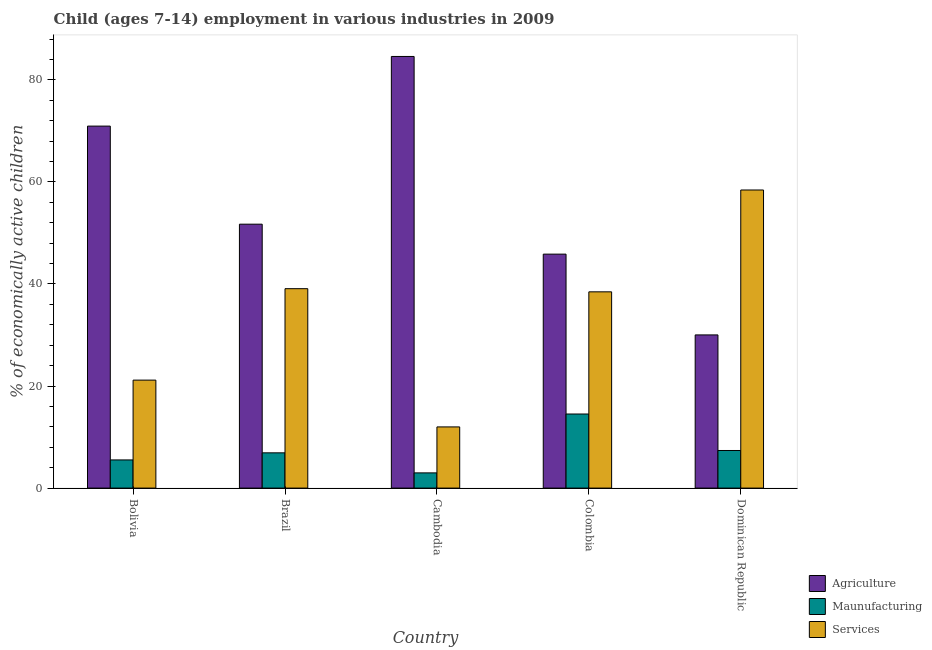How many different coloured bars are there?
Your answer should be compact. 3. Are the number of bars per tick equal to the number of legend labels?
Offer a very short reply. Yes. Are the number of bars on each tick of the X-axis equal?
Your response must be concise. Yes. How many bars are there on the 1st tick from the left?
Offer a very short reply. 3. What is the label of the 3rd group of bars from the left?
Keep it short and to the point. Cambodia. What is the percentage of economically active children in agriculture in Cambodia?
Offer a terse response. 84.59. Across all countries, what is the maximum percentage of economically active children in services?
Offer a terse response. 58.42. Across all countries, what is the minimum percentage of economically active children in manufacturing?
Keep it short and to the point. 2.98. In which country was the percentage of economically active children in services maximum?
Give a very brief answer. Dominican Republic. In which country was the percentage of economically active children in manufacturing minimum?
Ensure brevity in your answer.  Cambodia. What is the total percentage of economically active children in services in the graph?
Provide a short and direct response. 169.11. What is the difference between the percentage of economically active children in services in Cambodia and that in Colombia?
Offer a terse response. -26.47. What is the difference between the percentage of economically active children in services in Brazil and the percentage of economically active children in manufacturing in Colombia?
Provide a short and direct response. 24.56. What is the average percentage of economically active children in services per country?
Give a very brief answer. 33.82. What is the difference between the percentage of economically active children in agriculture and percentage of economically active children in services in Brazil?
Provide a succinct answer. 12.64. In how many countries, is the percentage of economically active children in manufacturing greater than 16 %?
Offer a very short reply. 0. What is the ratio of the percentage of economically active children in services in Brazil to that in Dominican Republic?
Offer a terse response. 0.67. What is the difference between the highest and the second highest percentage of economically active children in services?
Your response must be concise. 19.34. What is the difference between the highest and the lowest percentage of economically active children in services?
Make the answer very short. 46.43. In how many countries, is the percentage of economically active children in manufacturing greater than the average percentage of economically active children in manufacturing taken over all countries?
Provide a succinct answer. 1. Is the sum of the percentage of economically active children in manufacturing in Bolivia and Dominican Republic greater than the maximum percentage of economically active children in agriculture across all countries?
Ensure brevity in your answer.  No. What does the 2nd bar from the left in Colombia represents?
Ensure brevity in your answer.  Maunufacturing. What does the 2nd bar from the right in Bolivia represents?
Offer a very short reply. Maunufacturing. How many bars are there?
Ensure brevity in your answer.  15. Are all the bars in the graph horizontal?
Your answer should be compact. No. What is the difference between two consecutive major ticks on the Y-axis?
Ensure brevity in your answer.  20. Are the values on the major ticks of Y-axis written in scientific E-notation?
Your response must be concise. No. Where does the legend appear in the graph?
Offer a very short reply. Bottom right. How are the legend labels stacked?
Offer a terse response. Vertical. What is the title of the graph?
Ensure brevity in your answer.  Child (ages 7-14) employment in various industries in 2009. What is the label or title of the X-axis?
Offer a terse response. Country. What is the label or title of the Y-axis?
Your answer should be very brief. % of economically active children. What is the % of economically active children in Agriculture in Bolivia?
Offer a very short reply. 70.94. What is the % of economically active children of Maunufacturing in Bolivia?
Your answer should be compact. 5.52. What is the % of economically active children in Services in Bolivia?
Ensure brevity in your answer.  21.16. What is the % of economically active children of Agriculture in Brazil?
Your answer should be very brief. 51.72. What is the % of economically active children of Maunufacturing in Brazil?
Provide a succinct answer. 6.91. What is the % of economically active children of Services in Brazil?
Your answer should be very brief. 39.08. What is the % of economically active children of Agriculture in Cambodia?
Your answer should be compact. 84.59. What is the % of economically active children of Maunufacturing in Cambodia?
Offer a very short reply. 2.98. What is the % of economically active children in Services in Cambodia?
Give a very brief answer. 11.99. What is the % of economically active children in Agriculture in Colombia?
Your answer should be compact. 45.85. What is the % of economically active children in Maunufacturing in Colombia?
Make the answer very short. 14.52. What is the % of economically active children of Services in Colombia?
Make the answer very short. 38.46. What is the % of economically active children of Agriculture in Dominican Republic?
Your response must be concise. 30.02. What is the % of economically active children of Maunufacturing in Dominican Republic?
Offer a terse response. 7.37. What is the % of economically active children in Services in Dominican Republic?
Your response must be concise. 58.42. Across all countries, what is the maximum % of economically active children in Agriculture?
Make the answer very short. 84.59. Across all countries, what is the maximum % of economically active children in Maunufacturing?
Ensure brevity in your answer.  14.52. Across all countries, what is the maximum % of economically active children of Services?
Offer a very short reply. 58.42. Across all countries, what is the minimum % of economically active children in Agriculture?
Provide a succinct answer. 30.02. Across all countries, what is the minimum % of economically active children in Maunufacturing?
Make the answer very short. 2.98. Across all countries, what is the minimum % of economically active children of Services?
Offer a terse response. 11.99. What is the total % of economically active children in Agriculture in the graph?
Make the answer very short. 283.12. What is the total % of economically active children in Maunufacturing in the graph?
Your response must be concise. 37.3. What is the total % of economically active children of Services in the graph?
Keep it short and to the point. 169.11. What is the difference between the % of economically active children of Agriculture in Bolivia and that in Brazil?
Make the answer very short. 19.22. What is the difference between the % of economically active children in Maunufacturing in Bolivia and that in Brazil?
Keep it short and to the point. -1.39. What is the difference between the % of economically active children in Services in Bolivia and that in Brazil?
Provide a succinct answer. -17.92. What is the difference between the % of economically active children of Agriculture in Bolivia and that in Cambodia?
Provide a short and direct response. -13.65. What is the difference between the % of economically active children in Maunufacturing in Bolivia and that in Cambodia?
Offer a terse response. 2.54. What is the difference between the % of economically active children of Services in Bolivia and that in Cambodia?
Your answer should be compact. 9.17. What is the difference between the % of economically active children in Agriculture in Bolivia and that in Colombia?
Give a very brief answer. 25.09. What is the difference between the % of economically active children in Services in Bolivia and that in Colombia?
Your answer should be compact. -17.3. What is the difference between the % of economically active children of Agriculture in Bolivia and that in Dominican Republic?
Your answer should be very brief. 40.92. What is the difference between the % of economically active children of Maunufacturing in Bolivia and that in Dominican Republic?
Your answer should be very brief. -1.85. What is the difference between the % of economically active children in Services in Bolivia and that in Dominican Republic?
Provide a short and direct response. -37.26. What is the difference between the % of economically active children in Agriculture in Brazil and that in Cambodia?
Offer a terse response. -32.87. What is the difference between the % of economically active children in Maunufacturing in Brazil and that in Cambodia?
Provide a short and direct response. 3.93. What is the difference between the % of economically active children in Services in Brazil and that in Cambodia?
Your response must be concise. 27.09. What is the difference between the % of economically active children of Agriculture in Brazil and that in Colombia?
Make the answer very short. 5.87. What is the difference between the % of economically active children of Maunufacturing in Brazil and that in Colombia?
Make the answer very short. -7.61. What is the difference between the % of economically active children in Services in Brazil and that in Colombia?
Make the answer very short. 0.62. What is the difference between the % of economically active children in Agriculture in Brazil and that in Dominican Republic?
Keep it short and to the point. 21.7. What is the difference between the % of economically active children of Maunufacturing in Brazil and that in Dominican Republic?
Offer a very short reply. -0.46. What is the difference between the % of economically active children of Services in Brazil and that in Dominican Republic?
Provide a succinct answer. -19.34. What is the difference between the % of economically active children in Agriculture in Cambodia and that in Colombia?
Keep it short and to the point. 38.74. What is the difference between the % of economically active children in Maunufacturing in Cambodia and that in Colombia?
Offer a terse response. -11.54. What is the difference between the % of economically active children in Services in Cambodia and that in Colombia?
Offer a terse response. -26.47. What is the difference between the % of economically active children in Agriculture in Cambodia and that in Dominican Republic?
Provide a succinct answer. 54.57. What is the difference between the % of economically active children of Maunufacturing in Cambodia and that in Dominican Republic?
Ensure brevity in your answer.  -4.39. What is the difference between the % of economically active children in Services in Cambodia and that in Dominican Republic?
Offer a very short reply. -46.43. What is the difference between the % of economically active children of Agriculture in Colombia and that in Dominican Republic?
Your answer should be very brief. 15.83. What is the difference between the % of economically active children of Maunufacturing in Colombia and that in Dominican Republic?
Your response must be concise. 7.15. What is the difference between the % of economically active children of Services in Colombia and that in Dominican Republic?
Provide a succinct answer. -19.96. What is the difference between the % of economically active children of Agriculture in Bolivia and the % of economically active children of Maunufacturing in Brazil?
Give a very brief answer. 64.03. What is the difference between the % of economically active children of Agriculture in Bolivia and the % of economically active children of Services in Brazil?
Make the answer very short. 31.86. What is the difference between the % of economically active children of Maunufacturing in Bolivia and the % of economically active children of Services in Brazil?
Give a very brief answer. -33.56. What is the difference between the % of economically active children in Agriculture in Bolivia and the % of economically active children in Maunufacturing in Cambodia?
Your response must be concise. 67.96. What is the difference between the % of economically active children in Agriculture in Bolivia and the % of economically active children in Services in Cambodia?
Your answer should be very brief. 58.95. What is the difference between the % of economically active children of Maunufacturing in Bolivia and the % of economically active children of Services in Cambodia?
Ensure brevity in your answer.  -6.47. What is the difference between the % of economically active children in Agriculture in Bolivia and the % of economically active children in Maunufacturing in Colombia?
Offer a terse response. 56.42. What is the difference between the % of economically active children in Agriculture in Bolivia and the % of economically active children in Services in Colombia?
Your response must be concise. 32.48. What is the difference between the % of economically active children of Maunufacturing in Bolivia and the % of economically active children of Services in Colombia?
Your response must be concise. -32.94. What is the difference between the % of economically active children of Agriculture in Bolivia and the % of economically active children of Maunufacturing in Dominican Republic?
Provide a short and direct response. 63.57. What is the difference between the % of economically active children in Agriculture in Bolivia and the % of economically active children in Services in Dominican Republic?
Give a very brief answer. 12.52. What is the difference between the % of economically active children in Maunufacturing in Bolivia and the % of economically active children in Services in Dominican Republic?
Offer a very short reply. -52.9. What is the difference between the % of economically active children in Agriculture in Brazil and the % of economically active children in Maunufacturing in Cambodia?
Make the answer very short. 48.74. What is the difference between the % of economically active children in Agriculture in Brazil and the % of economically active children in Services in Cambodia?
Ensure brevity in your answer.  39.73. What is the difference between the % of economically active children of Maunufacturing in Brazil and the % of economically active children of Services in Cambodia?
Keep it short and to the point. -5.08. What is the difference between the % of economically active children of Agriculture in Brazil and the % of economically active children of Maunufacturing in Colombia?
Make the answer very short. 37.2. What is the difference between the % of economically active children in Agriculture in Brazil and the % of economically active children in Services in Colombia?
Offer a terse response. 13.26. What is the difference between the % of economically active children in Maunufacturing in Brazil and the % of economically active children in Services in Colombia?
Provide a succinct answer. -31.55. What is the difference between the % of economically active children in Agriculture in Brazil and the % of economically active children in Maunufacturing in Dominican Republic?
Your answer should be very brief. 44.35. What is the difference between the % of economically active children in Maunufacturing in Brazil and the % of economically active children in Services in Dominican Republic?
Provide a short and direct response. -51.51. What is the difference between the % of economically active children in Agriculture in Cambodia and the % of economically active children in Maunufacturing in Colombia?
Ensure brevity in your answer.  70.07. What is the difference between the % of economically active children of Agriculture in Cambodia and the % of economically active children of Services in Colombia?
Provide a succinct answer. 46.13. What is the difference between the % of economically active children of Maunufacturing in Cambodia and the % of economically active children of Services in Colombia?
Your response must be concise. -35.48. What is the difference between the % of economically active children of Agriculture in Cambodia and the % of economically active children of Maunufacturing in Dominican Republic?
Offer a terse response. 77.22. What is the difference between the % of economically active children of Agriculture in Cambodia and the % of economically active children of Services in Dominican Republic?
Offer a terse response. 26.17. What is the difference between the % of economically active children in Maunufacturing in Cambodia and the % of economically active children in Services in Dominican Republic?
Ensure brevity in your answer.  -55.44. What is the difference between the % of economically active children of Agriculture in Colombia and the % of economically active children of Maunufacturing in Dominican Republic?
Your response must be concise. 38.48. What is the difference between the % of economically active children of Agriculture in Colombia and the % of economically active children of Services in Dominican Republic?
Your answer should be very brief. -12.57. What is the difference between the % of economically active children of Maunufacturing in Colombia and the % of economically active children of Services in Dominican Republic?
Provide a short and direct response. -43.9. What is the average % of economically active children of Agriculture per country?
Offer a terse response. 56.62. What is the average % of economically active children in Maunufacturing per country?
Provide a succinct answer. 7.46. What is the average % of economically active children of Services per country?
Make the answer very short. 33.82. What is the difference between the % of economically active children in Agriculture and % of economically active children in Maunufacturing in Bolivia?
Give a very brief answer. 65.42. What is the difference between the % of economically active children in Agriculture and % of economically active children in Services in Bolivia?
Make the answer very short. 49.78. What is the difference between the % of economically active children of Maunufacturing and % of economically active children of Services in Bolivia?
Your answer should be compact. -15.64. What is the difference between the % of economically active children of Agriculture and % of economically active children of Maunufacturing in Brazil?
Keep it short and to the point. 44.81. What is the difference between the % of economically active children of Agriculture and % of economically active children of Services in Brazil?
Your response must be concise. 12.64. What is the difference between the % of economically active children in Maunufacturing and % of economically active children in Services in Brazil?
Offer a terse response. -32.17. What is the difference between the % of economically active children in Agriculture and % of economically active children in Maunufacturing in Cambodia?
Your answer should be compact. 81.61. What is the difference between the % of economically active children in Agriculture and % of economically active children in Services in Cambodia?
Ensure brevity in your answer.  72.6. What is the difference between the % of economically active children of Maunufacturing and % of economically active children of Services in Cambodia?
Your answer should be very brief. -9.01. What is the difference between the % of economically active children of Agriculture and % of economically active children of Maunufacturing in Colombia?
Make the answer very short. 31.33. What is the difference between the % of economically active children in Agriculture and % of economically active children in Services in Colombia?
Keep it short and to the point. 7.39. What is the difference between the % of economically active children of Maunufacturing and % of economically active children of Services in Colombia?
Provide a short and direct response. -23.94. What is the difference between the % of economically active children of Agriculture and % of economically active children of Maunufacturing in Dominican Republic?
Provide a succinct answer. 22.65. What is the difference between the % of economically active children of Agriculture and % of economically active children of Services in Dominican Republic?
Your response must be concise. -28.4. What is the difference between the % of economically active children in Maunufacturing and % of economically active children in Services in Dominican Republic?
Your answer should be compact. -51.05. What is the ratio of the % of economically active children in Agriculture in Bolivia to that in Brazil?
Ensure brevity in your answer.  1.37. What is the ratio of the % of economically active children in Maunufacturing in Bolivia to that in Brazil?
Keep it short and to the point. 0.8. What is the ratio of the % of economically active children of Services in Bolivia to that in Brazil?
Your answer should be compact. 0.54. What is the ratio of the % of economically active children of Agriculture in Bolivia to that in Cambodia?
Your response must be concise. 0.84. What is the ratio of the % of economically active children in Maunufacturing in Bolivia to that in Cambodia?
Offer a very short reply. 1.85. What is the ratio of the % of economically active children in Services in Bolivia to that in Cambodia?
Your answer should be very brief. 1.76. What is the ratio of the % of economically active children in Agriculture in Bolivia to that in Colombia?
Your response must be concise. 1.55. What is the ratio of the % of economically active children in Maunufacturing in Bolivia to that in Colombia?
Give a very brief answer. 0.38. What is the ratio of the % of economically active children in Services in Bolivia to that in Colombia?
Make the answer very short. 0.55. What is the ratio of the % of economically active children of Agriculture in Bolivia to that in Dominican Republic?
Offer a very short reply. 2.36. What is the ratio of the % of economically active children in Maunufacturing in Bolivia to that in Dominican Republic?
Offer a terse response. 0.75. What is the ratio of the % of economically active children of Services in Bolivia to that in Dominican Republic?
Offer a very short reply. 0.36. What is the ratio of the % of economically active children in Agriculture in Brazil to that in Cambodia?
Offer a terse response. 0.61. What is the ratio of the % of economically active children in Maunufacturing in Brazil to that in Cambodia?
Provide a succinct answer. 2.32. What is the ratio of the % of economically active children in Services in Brazil to that in Cambodia?
Offer a very short reply. 3.26. What is the ratio of the % of economically active children in Agriculture in Brazil to that in Colombia?
Offer a terse response. 1.13. What is the ratio of the % of economically active children in Maunufacturing in Brazil to that in Colombia?
Ensure brevity in your answer.  0.48. What is the ratio of the % of economically active children in Services in Brazil to that in Colombia?
Your response must be concise. 1.02. What is the ratio of the % of economically active children of Agriculture in Brazil to that in Dominican Republic?
Offer a very short reply. 1.72. What is the ratio of the % of economically active children of Maunufacturing in Brazil to that in Dominican Republic?
Offer a terse response. 0.94. What is the ratio of the % of economically active children of Services in Brazil to that in Dominican Republic?
Your answer should be very brief. 0.67. What is the ratio of the % of economically active children in Agriculture in Cambodia to that in Colombia?
Your answer should be compact. 1.84. What is the ratio of the % of economically active children in Maunufacturing in Cambodia to that in Colombia?
Ensure brevity in your answer.  0.21. What is the ratio of the % of economically active children of Services in Cambodia to that in Colombia?
Provide a succinct answer. 0.31. What is the ratio of the % of economically active children of Agriculture in Cambodia to that in Dominican Republic?
Make the answer very short. 2.82. What is the ratio of the % of economically active children of Maunufacturing in Cambodia to that in Dominican Republic?
Your answer should be compact. 0.4. What is the ratio of the % of economically active children in Services in Cambodia to that in Dominican Republic?
Ensure brevity in your answer.  0.21. What is the ratio of the % of economically active children of Agriculture in Colombia to that in Dominican Republic?
Your answer should be compact. 1.53. What is the ratio of the % of economically active children in Maunufacturing in Colombia to that in Dominican Republic?
Your response must be concise. 1.97. What is the ratio of the % of economically active children in Services in Colombia to that in Dominican Republic?
Offer a terse response. 0.66. What is the difference between the highest and the second highest % of economically active children in Agriculture?
Your answer should be compact. 13.65. What is the difference between the highest and the second highest % of economically active children in Maunufacturing?
Offer a very short reply. 7.15. What is the difference between the highest and the second highest % of economically active children of Services?
Your answer should be very brief. 19.34. What is the difference between the highest and the lowest % of economically active children of Agriculture?
Make the answer very short. 54.57. What is the difference between the highest and the lowest % of economically active children of Maunufacturing?
Your answer should be compact. 11.54. What is the difference between the highest and the lowest % of economically active children in Services?
Offer a terse response. 46.43. 